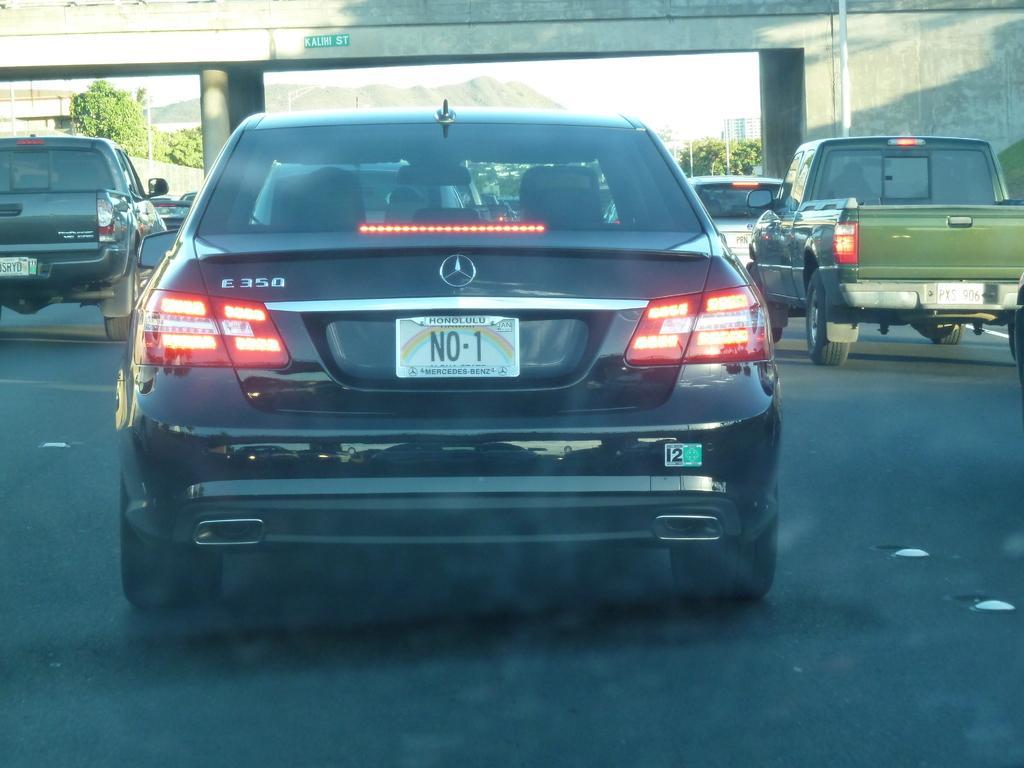How would you summarize this image in a sentence or two? In this image we can see vehicles on the road. In the background there is a bridge, poles, trees, buildings, mountain and sky. 